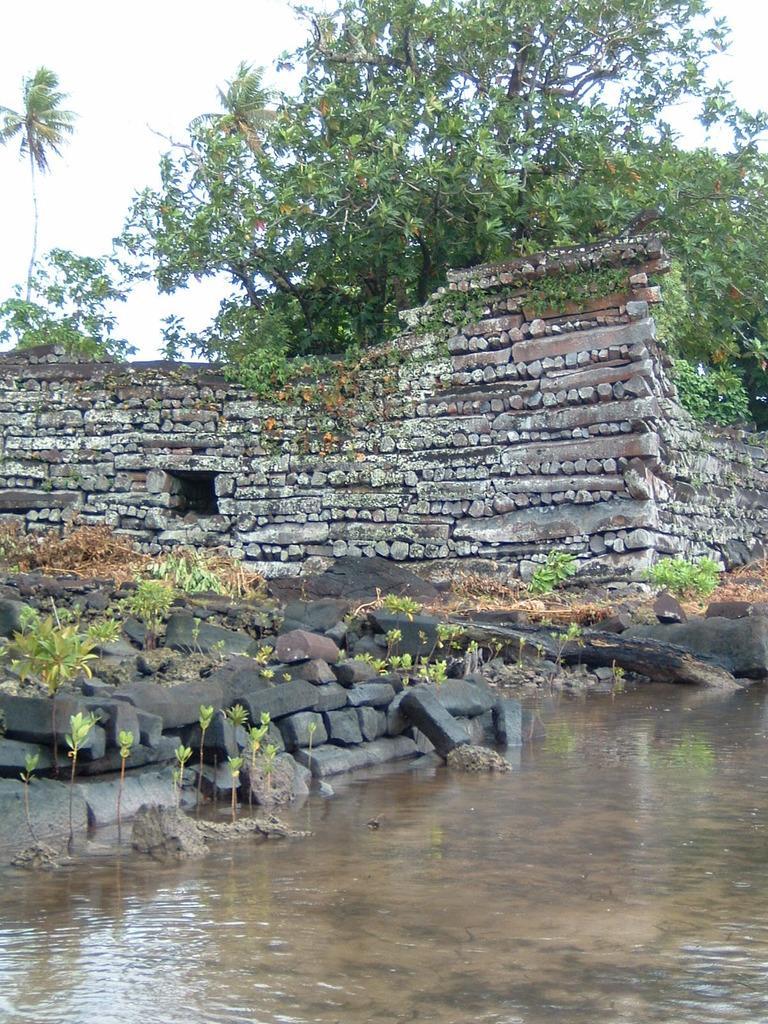In one or two sentences, can you explain what this image depicts? In this image we can see the pond and there are some plants and rocks and we can see the stone structure in the background and there are some trees. We can see the sky at the top. 